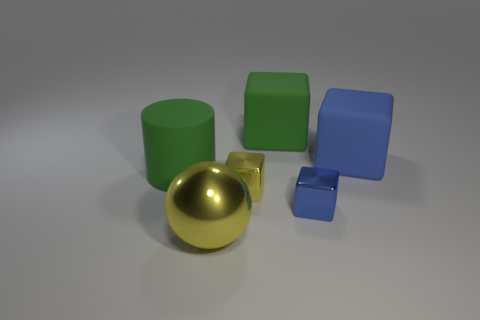Subtract all brown blocks. Subtract all gray cylinders. How many blocks are left? 4 Add 3 purple matte things. How many objects exist? 9 Subtract all cylinders. How many objects are left? 5 Subtract all green objects. Subtract all big blue rubber things. How many objects are left? 3 Add 4 green objects. How many green objects are left? 6 Add 1 small yellow metallic objects. How many small yellow metallic objects exist? 2 Subtract 1 green cylinders. How many objects are left? 5 